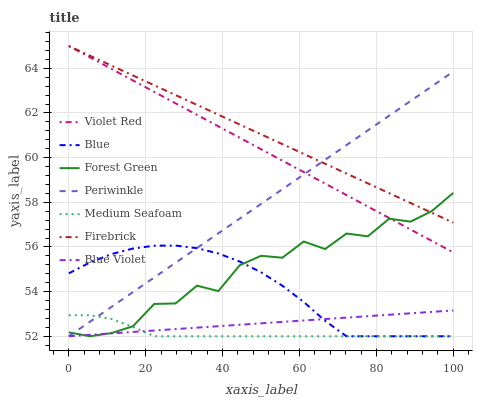Does Medium Seafoam have the minimum area under the curve?
Answer yes or no. Yes. Does Firebrick have the maximum area under the curve?
Answer yes or no. Yes. Does Violet Red have the minimum area under the curve?
Answer yes or no. No. Does Violet Red have the maximum area under the curve?
Answer yes or no. No. Is Firebrick the smoothest?
Answer yes or no. Yes. Is Forest Green the roughest?
Answer yes or no. Yes. Is Violet Red the smoothest?
Answer yes or no. No. Is Violet Red the roughest?
Answer yes or no. No. Does Blue have the lowest value?
Answer yes or no. Yes. Does Violet Red have the lowest value?
Answer yes or no. No. Does Firebrick have the highest value?
Answer yes or no. Yes. Does Forest Green have the highest value?
Answer yes or no. No. Is Medium Seafoam less than Violet Red?
Answer yes or no. Yes. Is Violet Red greater than Medium Seafoam?
Answer yes or no. Yes. Does Firebrick intersect Forest Green?
Answer yes or no. Yes. Is Firebrick less than Forest Green?
Answer yes or no. No. Is Firebrick greater than Forest Green?
Answer yes or no. No. Does Medium Seafoam intersect Violet Red?
Answer yes or no. No. 